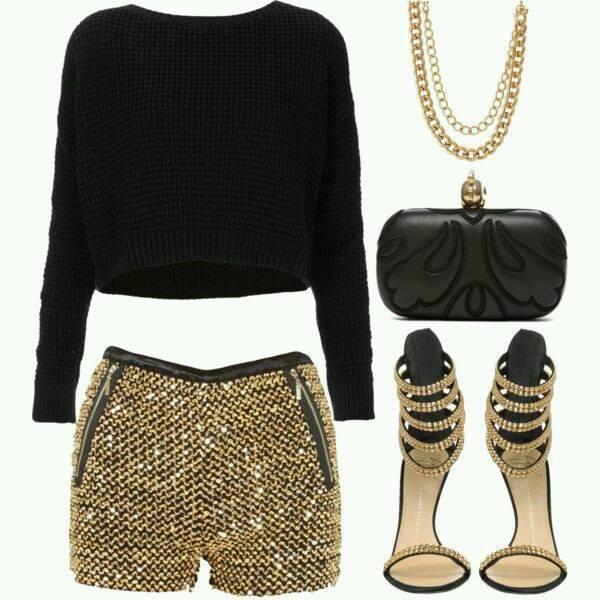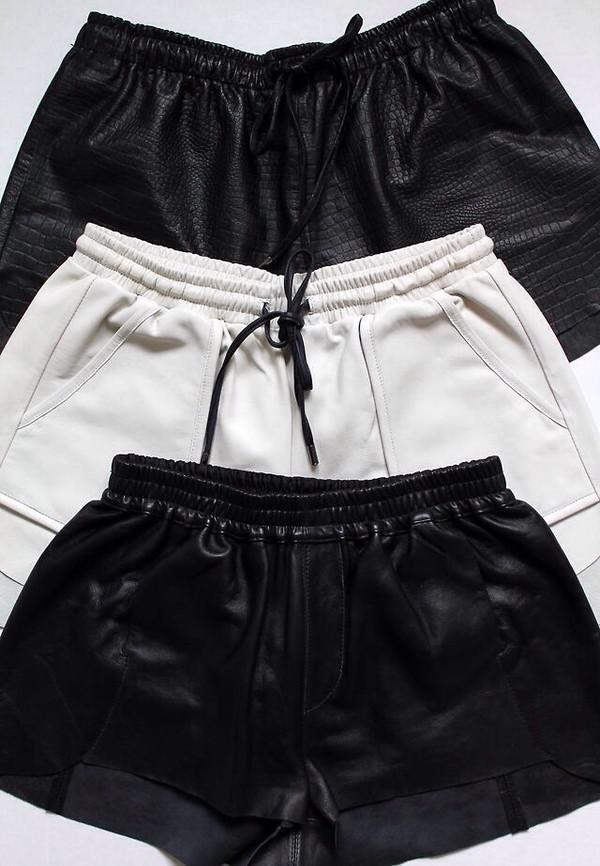The first image is the image on the left, the second image is the image on the right. For the images shown, is this caption "the left image has a necklace and shoes" true? Answer yes or no. Yes. The first image is the image on the left, the second image is the image on the right. For the images shown, is this caption "There are two sets of female pajamas - one of which is of the color gold." true? Answer yes or no. No. 